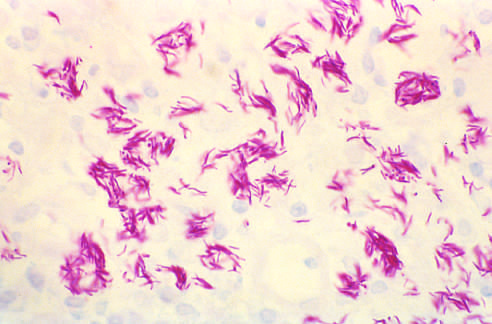what does not occur in the absence of appropriate t-cell-mediated immunity?
Answer the question using a single word or phrase. Granulomatous host response 